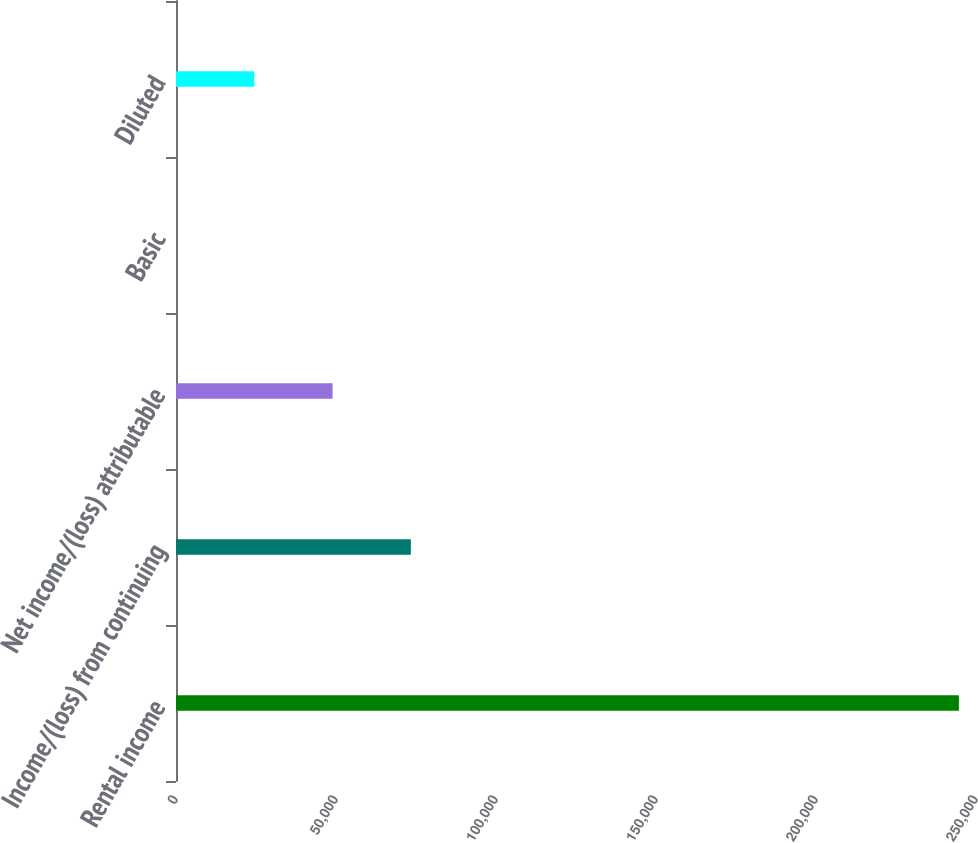<chart> <loc_0><loc_0><loc_500><loc_500><bar_chart><fcel>Rental income<fcel>Income/(loss) from continuing<fcel>Net income/(loss) attributable<fcel>Basic<fcel>Diluted<nl><fcel>244658<fcel>73397.4<fcel>48931.6<fcel>0.03<fcel>24465.8<nl></chart> 